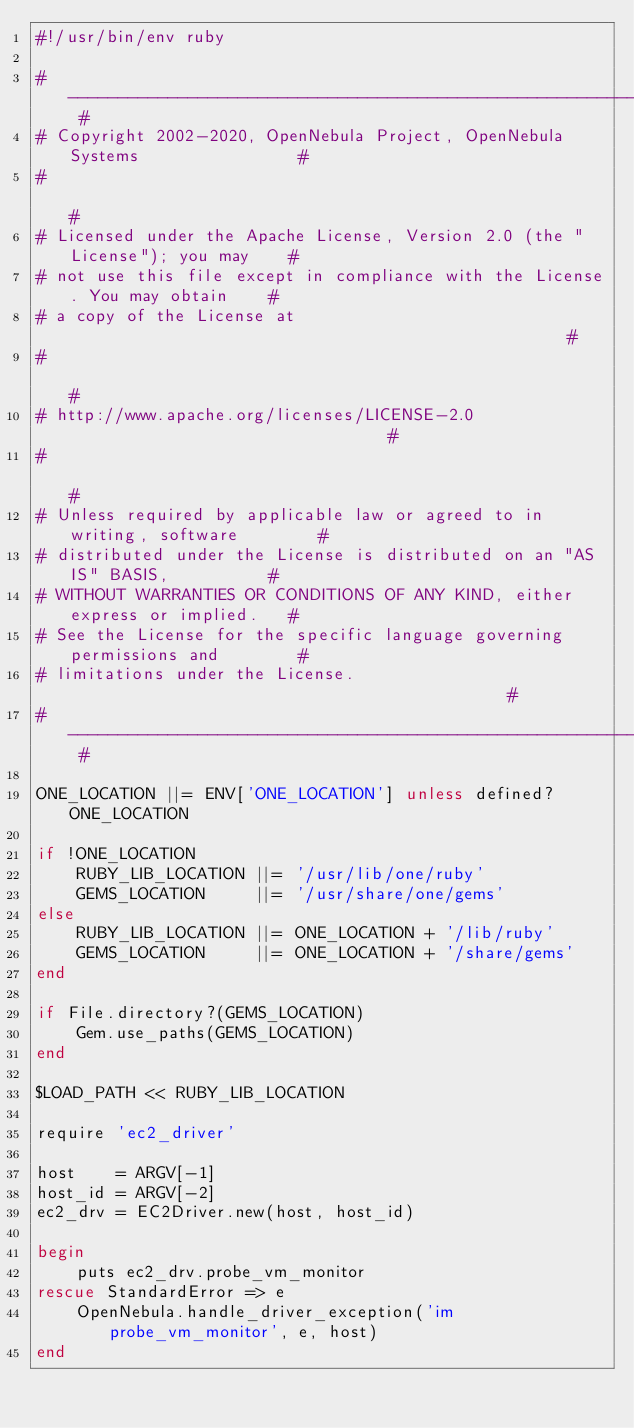Convert code to text. <code><loc_0><loc_0><loc_500><loc_500><_Ruby_>#!/usr/bin/env ruby

# -------------------------------------------------------------------------- #
# Copyright 2002-2020, OpenNebula Project, OpenNebula Systems                #
#                                                                            #
# Licensed under the Apache License, Version 2.0 (the "License"); you may    #
# not use this file except in compliance with the License. You may obtain    #
# a copy of the License at                                                   #
#                                                                            #
# http://www.apache.org/licenses/LICENSE-2.0                                 #
#                                                                            #
# Unless required by applicable law or agreed to in writing, software        #
# distributed under the License is distributed on an "AS IS" BASIS,          #
# WITHOUT WARRANTIES OR CONDITIONS OF ANY KIND, either express or implied.   #
# See the License for the specific language governing permissions and        #
# limitations under the License.                                             #
# -------------------------------------------------------------------------- #

ONE_LOCATION ||= ENV['ONE_LOCATION'] unless defined? ONE_LOCATION

if !ONE_LOCATION
    RUBY_LIB_LOCATION ||= '/usr/lib/one/ruby'
    GEMS_LOCATION     ||= '/usr/share/one/gems'
else
    RUBY_LIB_LOCATION ||= ONE_LOCATION + '/lib/ruby'
    GEMS_LOCATION     ||= ONE_LOCATION + '/share/gems'
end

if File.directory?(GEMS_LOCATION)
    Gem.use_paths(GEMS_LOCATION)
end

$LOAD_PATH << RUBY_LIB_LOCATION

require 'ec2_driver'

host    = ARGV[-1]
host_id = ARGV[-2]
ec2_drv = EC2Driver.new(host, host_id)

begin
    puts ec2_drv.probe_vm_monitor
rescue StandardError => e
    OpenNebula.handle_driver_exception('im probe_vm_monitor', e, host)
end
</code> 